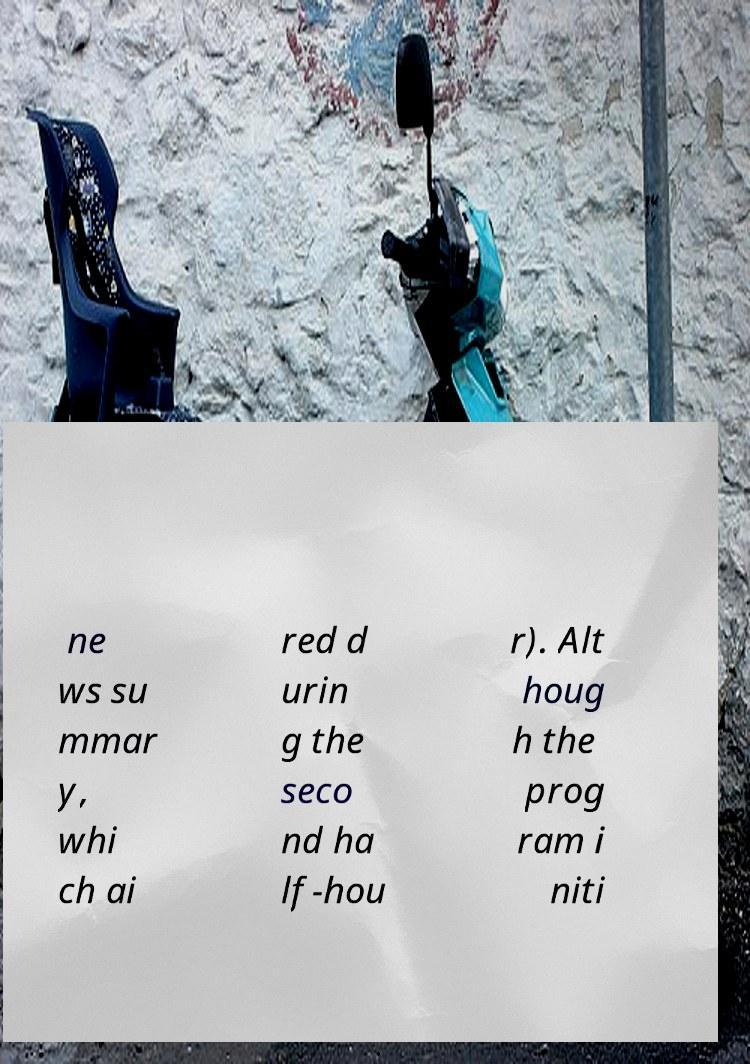Can you read and provide the text displayed in the image?This photo seems to have some interesting text. Can you extract and type it out for me? ne ws su mmar y, whi ch ai red d urin g the seco nd ha lf-hou r). Alt houg h the prog ram i niti 